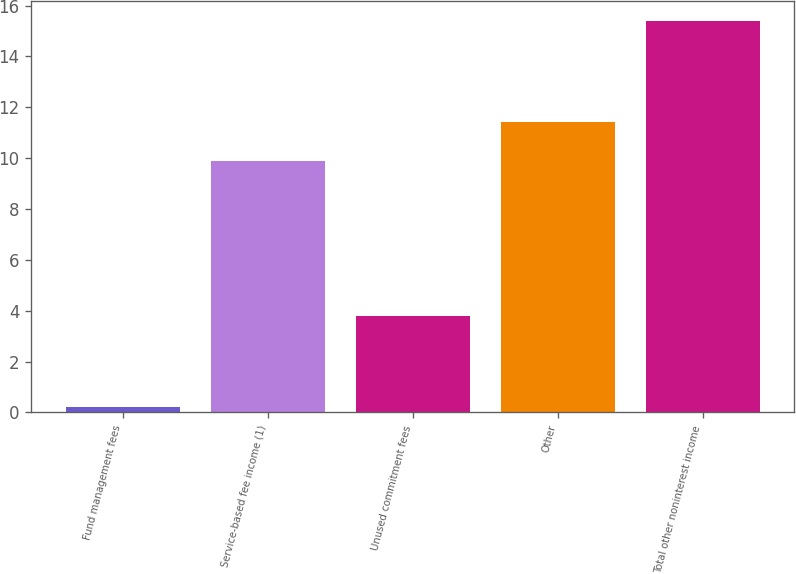Convert chart to OTSL. <chart><loc_0><loc_0><loc_500><loc_500><bar_chart><fcel>Fund management fees<fcel>Service-based fee income (1)<fcel>Unused commitment fees<fcel>Other<fcel>Total other noninterest income<nl><fcel>0.2<fcel>9.9<fcel>3.8<fcel>11.42<fcel>15.4<nl></chart> 